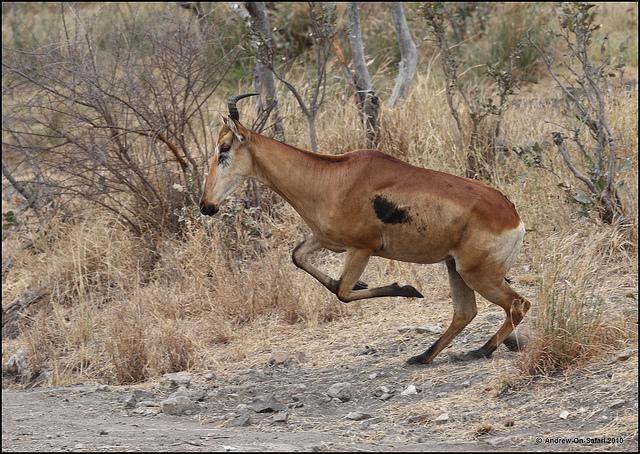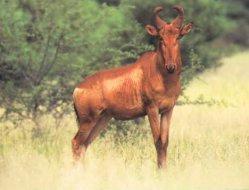The first image is the image on the left, the second image is the image on the right. Examine the images to the left and right. Is the description "In one image, a mammal figure is behind a horned animal." accurate? Answer yes or no. No. 